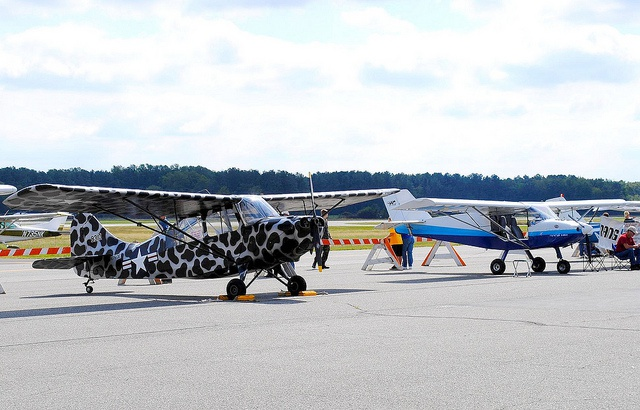Describe the objects in this image and their specific colors. I can see airplane in white, black, gray, darkgray, and lightgray tones, airplane in white, navy, lightgray, and darkgray tones, airplane in white, lightgray, darkgray, gray, and black tones, people in white, black, maroon, navy, and darkgray tones, and people in white, black, gray, and darkgray tones in this image. 